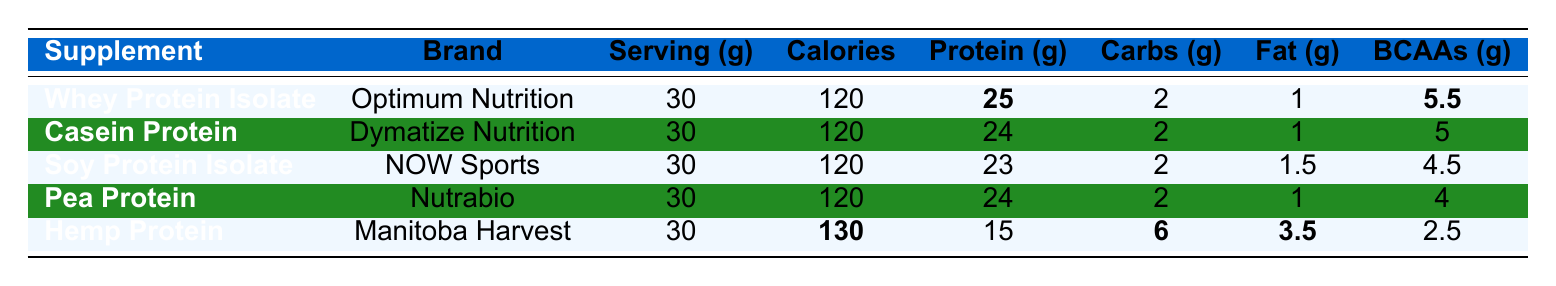What protein supplement has the highest protein content per serving? Referring to the table, Whey Protein Isolate has the highest protein content at 25 grams per serving, compared to the others.
Answer: Whey Protein Isolate What is the calorie content of Hemp Protein? Looking at the table, Hemp Protein has a calorie content of 130 calories per serving.
Answer: 130 calories Which supplement has the lowest fat content? From the table, both Whey Protein Isolate, Casein Protein, and Pea Protein have the same lowest fat content of 1 gram per serving.
Answer: 1 gram How many grams of BCAAs does Soy Protein Isolate contain? According to the table, Soy Protein Isolate contains 4.5 grams of BCAAs.
Answer: 4.5 grams What is the total protein content of Casein Protein and Pea Protein combined? The protein content for Casein Protein is 24 grams and for Pea Protein is 24 grams, adding them together gives 24 + 24 = 48 grams.
Answer: 48 grams Is the carbohydrate content the same for all protein supplements listed? The table shows that all protein supplements have 2 grams of carbohydrates except for Hemp Protein, which has 6 grams. Thus, the statement is false.
Answer: No What is the average protein content across all five supplements? The protein contents are 25, 24, 23, 24, and 15 grams. Adding these gives 25 + 24 + 23 + 24 + 15 = 111 grams, and dividing by 5 gives an average of 111/5 = 22.2 grams.
Answer: 22.2 grams Which supplement has the highest BCAAs content, and what is that amount? The table reveals that Whey Protein Isolate has the highest BCAAs content at 5.5 grams.
Answer: 5.5 grams How many total grams of carbohydrates are present in all protein supplements combined? The carbohydrate contents are 2, 2, 2, 2, and 6 grams, summing these gives 2 + 2 + 2 + 2 + 6 = 14 grams.
Answer: 14 grams If you wanted to reduce fat intake, which supplement would you prefer based on this table? Both Whey Protein Isolate, Casein Protein, and Pea Protein have the lowest fat content of 1 gram, making any of these suitable for reducing fat intake.
Answer: Whey Protein Isolate, Casein Protein, or Pea Protein 